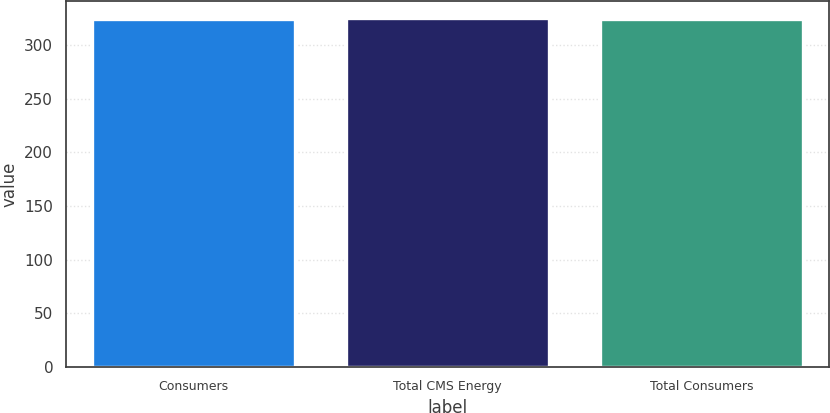Convert chart to OTSL. <chart><loc_0><loc_0><loc_500><loc_500><bar_chart><fcel>Consumers<fcel>Total CMS Energy<fcel>Total Consumers<nl><fcel>324<fcel>325<fcel>324.1<nl></chart> 